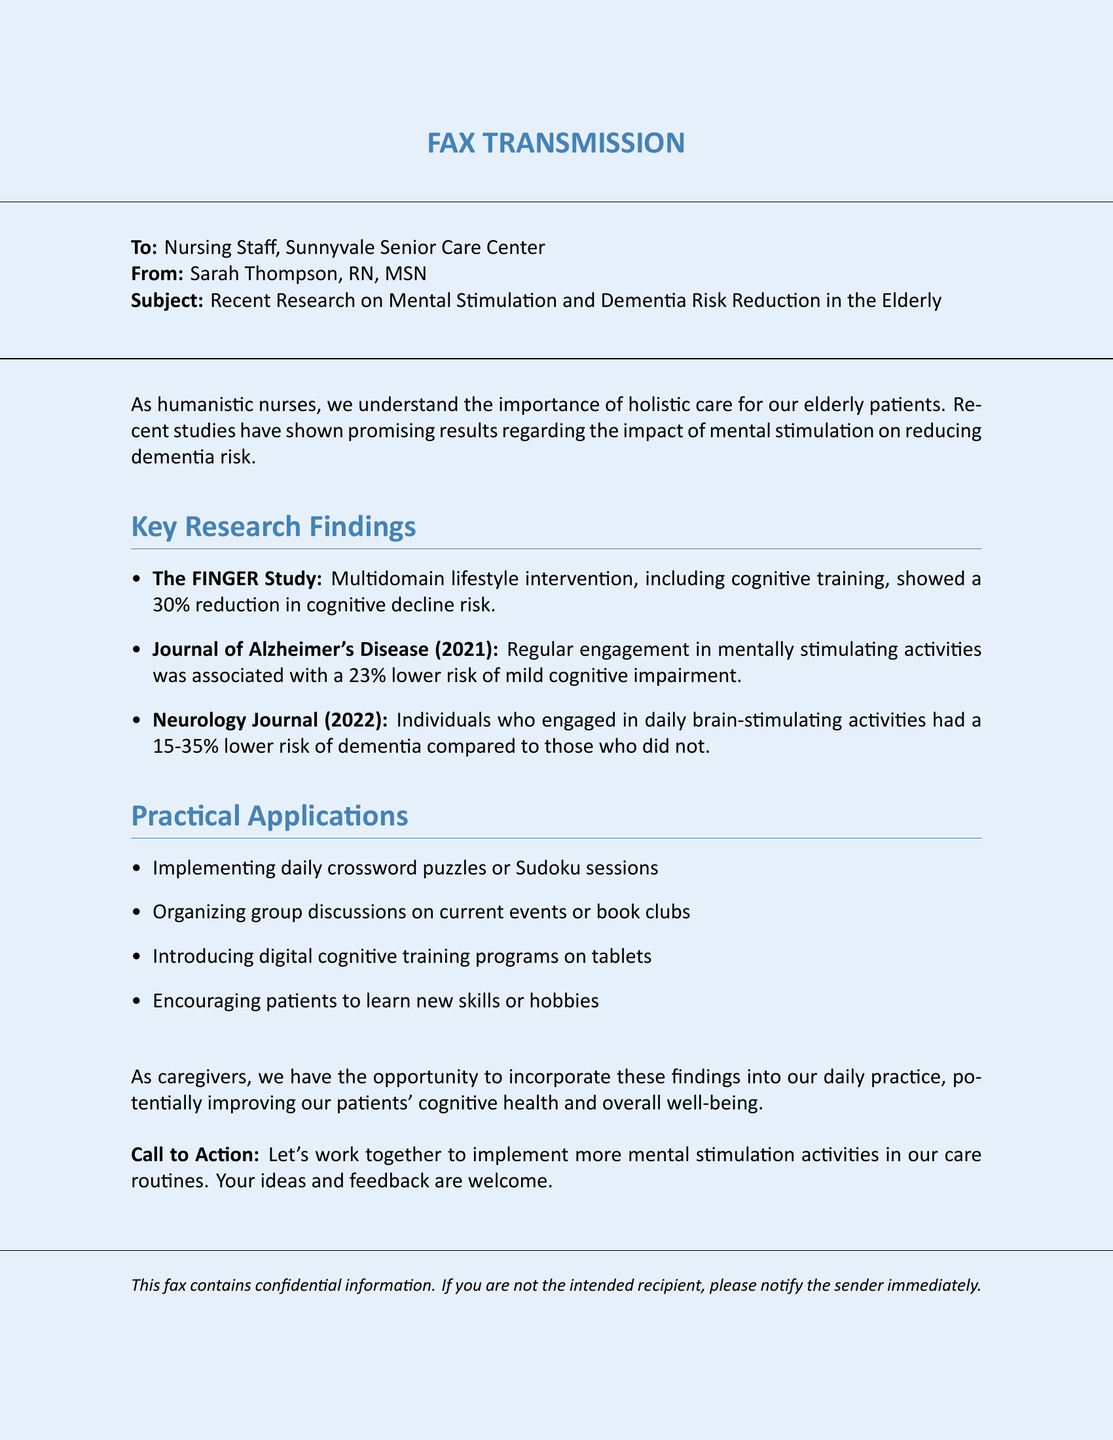what is the subject of the fax? The subject is indicated in the subject line of the fax, which details the recent research on mental stimulation and dementia risk reduction.
Answer: Recent Research on Mental Stimulation and Dementia Risk Reduction in the Elderly who is the sender of this fax? The sender's name is provided in the header, along with their qualifications.
Answer: Sarah Thompson, RN, MSN what was the percentage reduction in cognitive decline according to The FINGER Study? The document states a specific percentage reduction based on the results of The FINGER Study.
Answer: 30% which journal published findings regarding a 23% lower risk of mild cognitive impairment? The document references a specific journal that published this finding.
Answer: Journal of Alzheimer's Disease list one recommended activity to promote mental stimulation mentioned in the document. The document outlines various practical applications for mental stimulation.
Answer: Crossword puzzles or Sudoku sessions how much lower is the dementia risk for individuals engaging in daily brain-stimulating activities according to the Neurology Journal? The document provides a range for the percentage reduction in dementia risk.
Answer: 15-35% what is suggested as a call to action at the end of the document? The call to action encourages certain actions among the caregivers.
Answer: Implement more mental stimulation activities what type of document is this? The format and context indicate the nature of this document.
Answer: Fax 